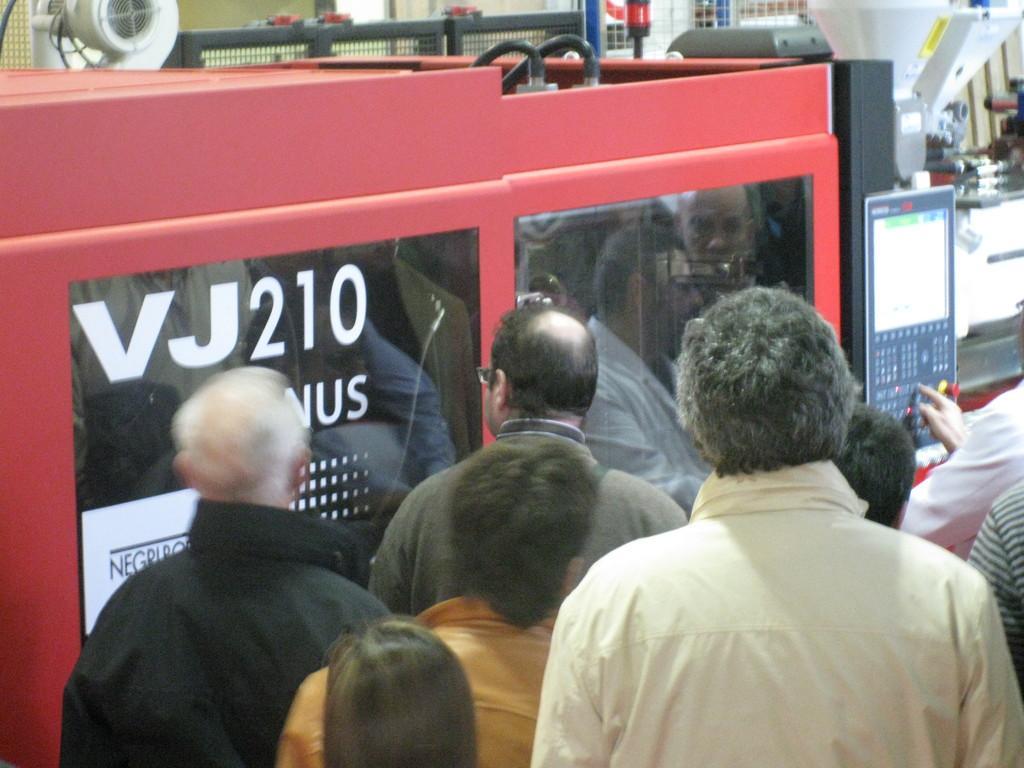How would you summarize this image in a sentence or two? In this image I can see few machines and few people and I can see the person's figure on the button. Back I can see few objects. 